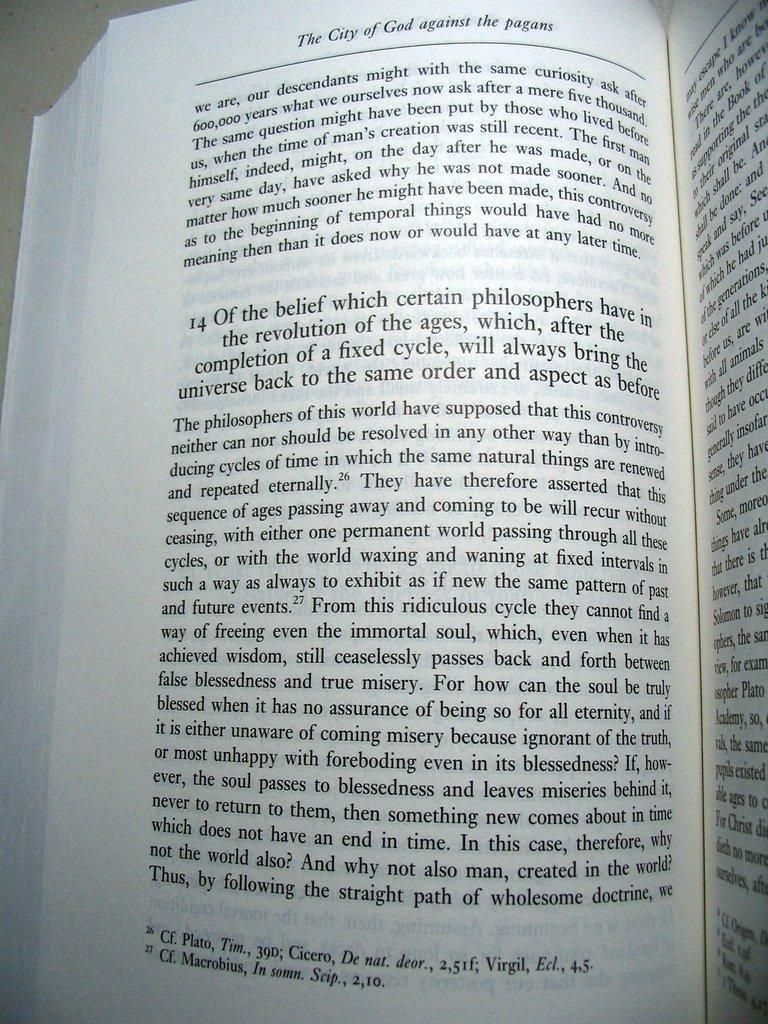<image>
Relay a brief, clear account of the picture shown. A book titled The City of God against the Pagans is opened 